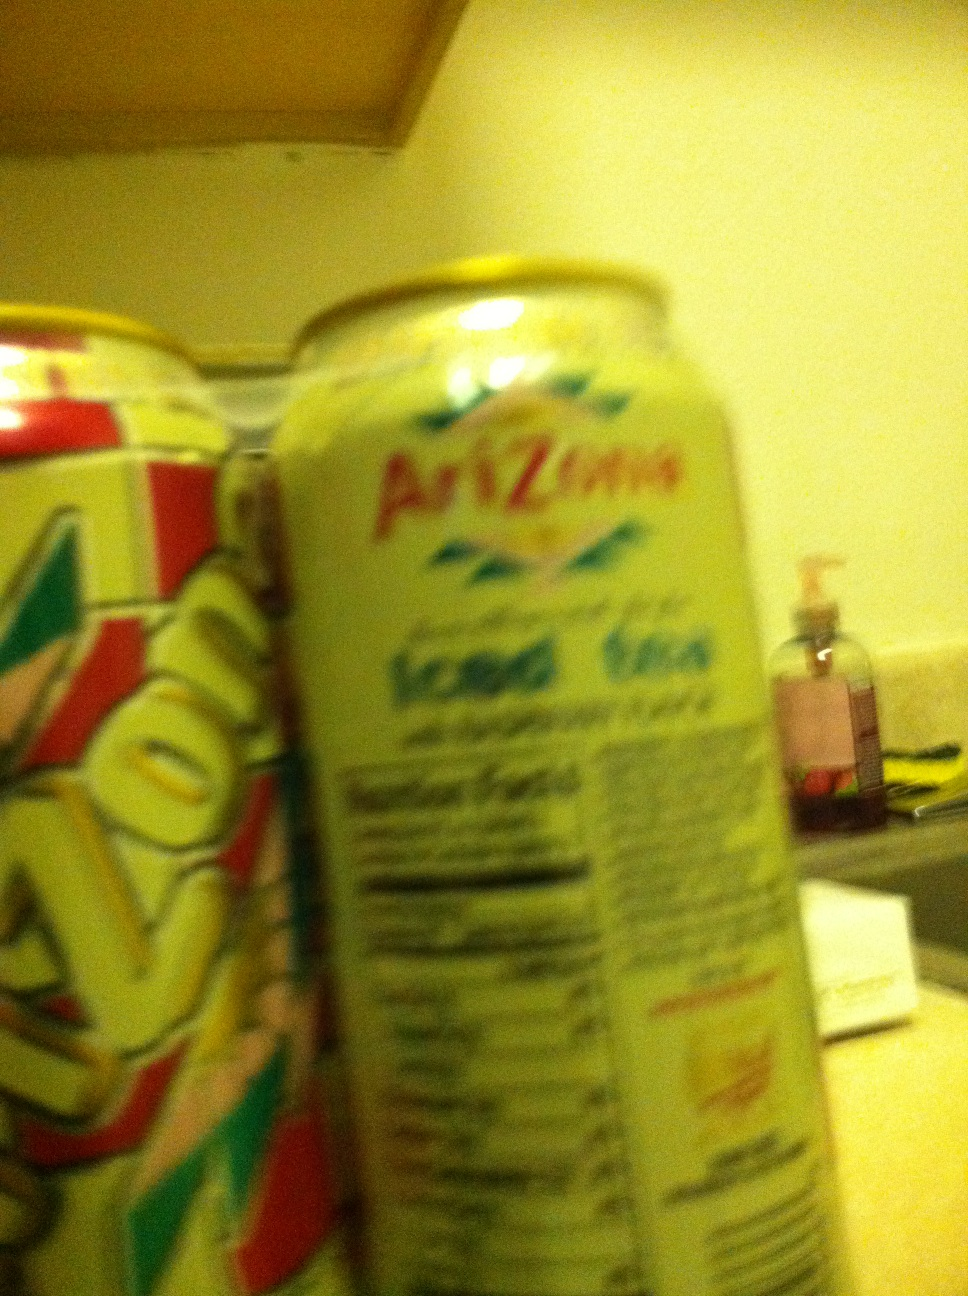Why is Arizona's Green Tea with Ginseng and Honey flapavor significant in the market? Arizona's Green Tea with Ginseng and Honey is significant due to its blend of natural ingredients that cater to health-conscious consumers. It combines the antioxidant properties of green tea with the invigorating qualities of ginseng and the natural sweetness of honey, positioning it as a healthy alternative to sugary sodas. How has the packaging design contributed to its brand recognition? The packaging design of Arizona Iced Tea, characterized by its vibrant and distinct motifs, has significantly contributed to its brand recognition. The large, bold fonts and decorative themes reflect a unique visual identity that stands out on store shelves, helping establish a strong consumer connection. 